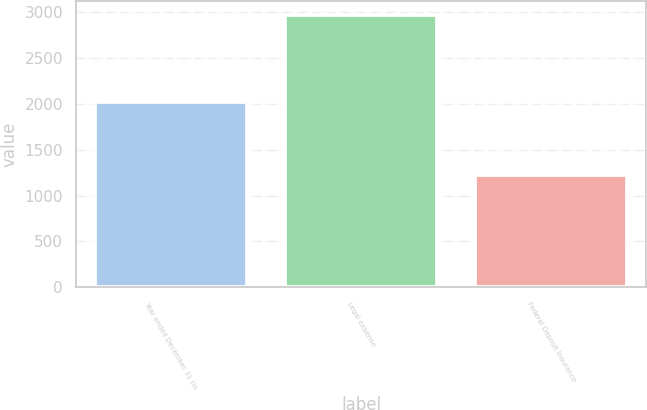<chart> <loc_0><loc_0><loc_500><loc_500><bar_chart><fcel>Year ended December 31 (in<fcel>Legal expense<fcel>Federal Deposit Insurance<nl><fcel>2015<fcel>2969<fcel>1227<nl></chart> 